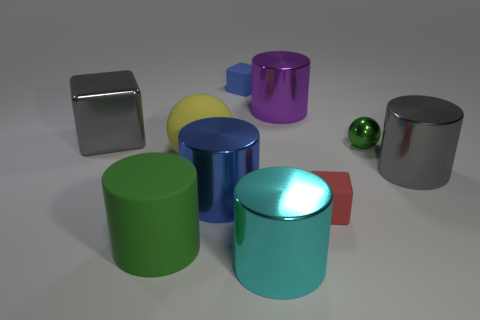Is there any other thing that has the same color as the large ball?
Provide a short and direct response. No. What is the shape of the large thing that is both behind the big ball and on the right side of the big cyan thing?
Provide a short and direct response. Cylinder. There is a sphere that is the same size as the purple cylinder; what is its color?
Ensure brevity in your answer.  Yellow. Is the size of the gray block behind the big cyan shiny cylinder the same as the green cylinder left of the large blue metallic thing?
Give a very brief answer. Yes. How big is the shiny cylinder that is on the left side of the cyan thing to the left of the block that is on the right side of the large purple object?
Your answer should be compact. Large. There is a big gray metal thing right of the gray metallic object left of the tiny red thing; what shape is it?
Offer a very short reply. Cylinder. Is the color of the large metallic thing on the right side of the purple shiny thing the same as the big block?
Offer a terse response. Yes. There is a big thing that is both left of the yellow ball and behind the big matte cylinder; what is its color?
Offer a very short reply. Gray. Are there any things made of the same material as the yellow sphere?
Make the answer very short. Yes. What is the size of the blue matte cube?
Ensure brevity in your answer.  Small. 